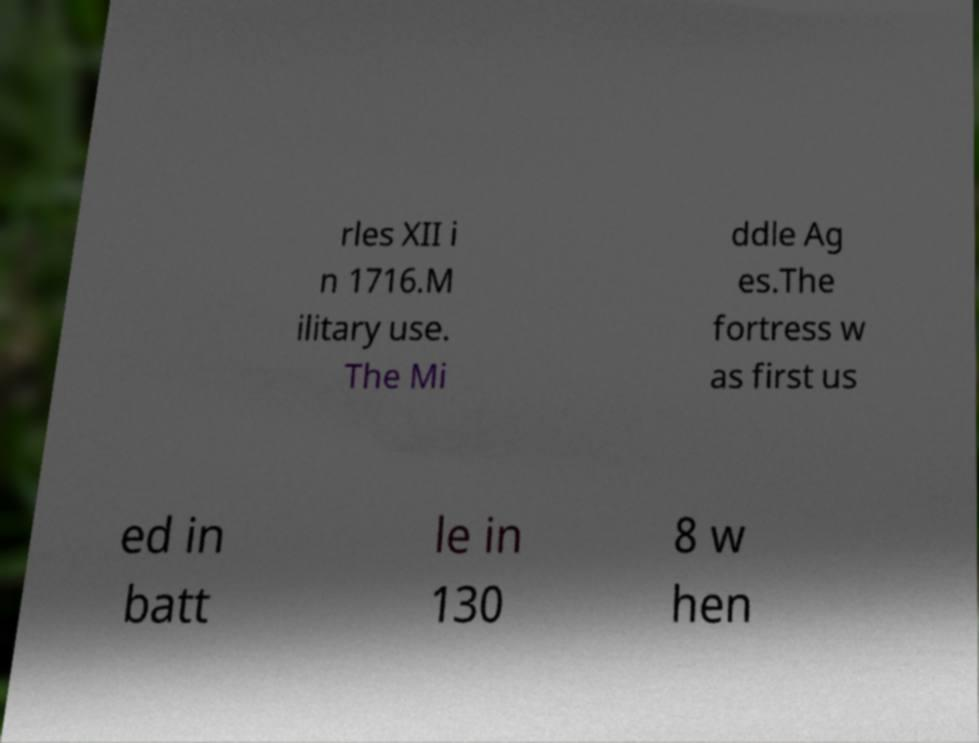Could you extract and type out the text from this image? rles XII i n 1716.M ilitary use. The Mi ddle Ag es.The fortress w as first us ed in batt le in 130 8 w hen 